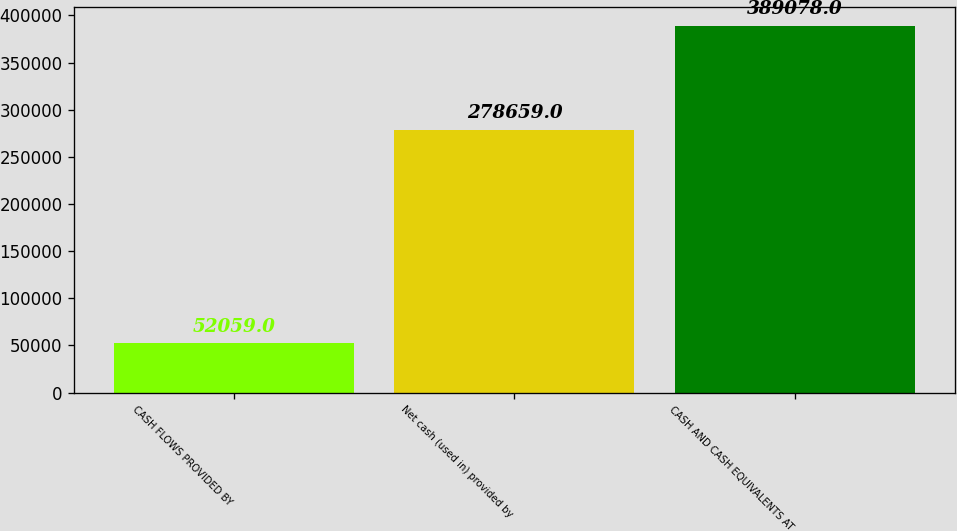Convert chart to OTSL. <chart><loc_0><loc_0><loc_500><loc_500><bar_chart><fcel>CASH FLOWS PROVIDED BY<fcel>Net cash (used in) provided by<fcel>CASH AND CASH EQUIVALENTS AT<nl><fcel>52059<fcel>278659<fcel>389078<nl></chart> 